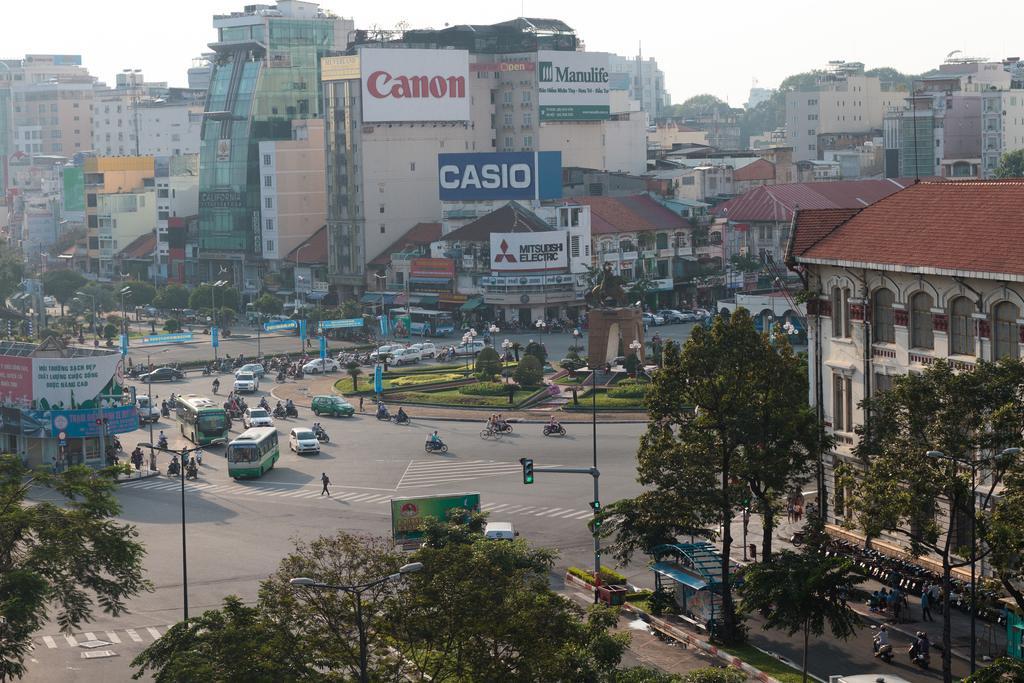In one or two sentences, can you explain what this image depicts? This is the aerial view image of a town in which there is a junction in the middle. On the road there are so many vehicles and few people are walking on it. In the background there are so many buildings one beside the other. There are hoardings attached to the buildings. At the bottom there are trees. On the footpath there are traffic signal lights and electric poles. On the left side it looks like a bus stand. 